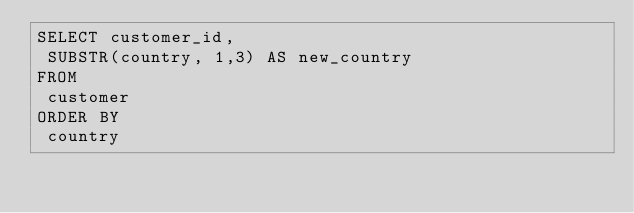<code> <loc_0><loc_0><loc_500><loc_500><_SQL_>SELECT customer_id,
 SUBSTR(country, 1,3) AS new_country
FROM
 customer
ORDER BY
 country
</code> 